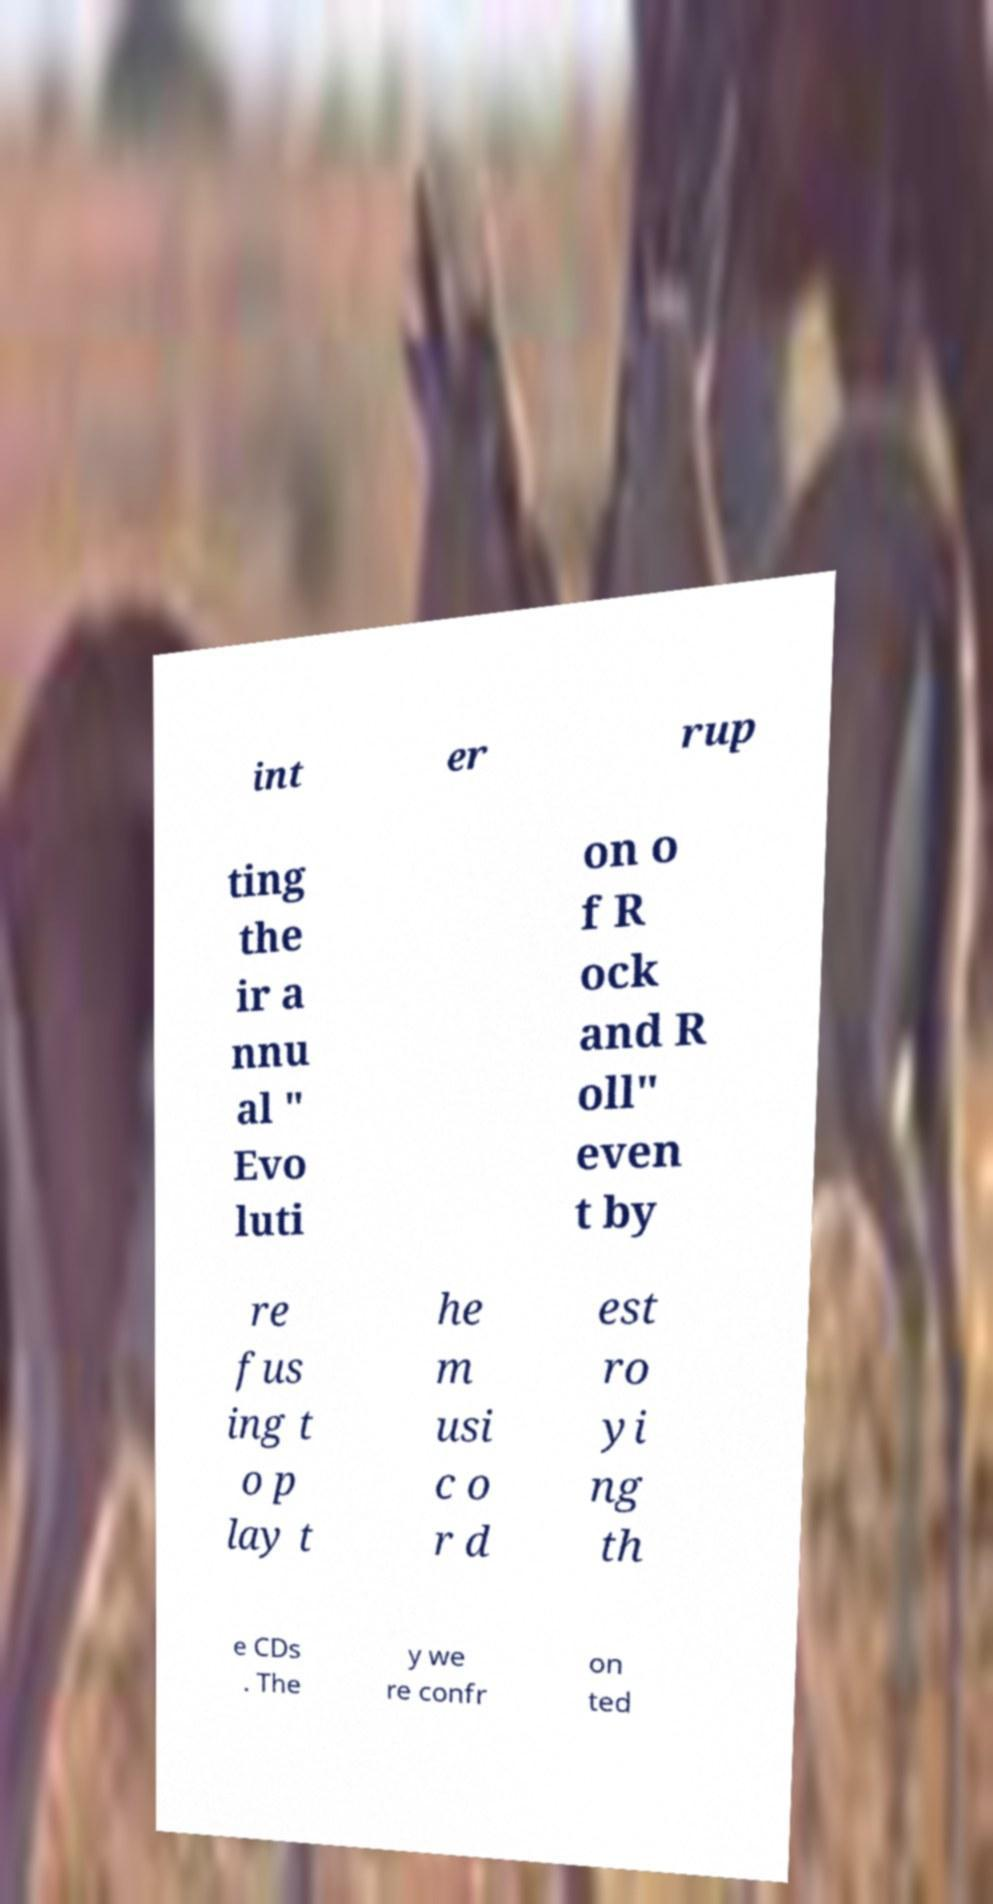Please read and relay the text visible in this image. What does it say? int er rup ting the ir a nnu al " Evo luti on o f R ock and R oll" even t by re fus ing t o p lay t he m usi c o r d est ro yi ng th e CDs . The y we re confr on ted 